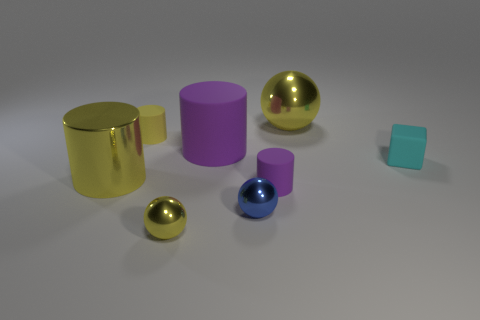Add 1 small blue spheres. How many objects exist? 9 Subtract all yellow matte cylinders. How many cylinders are left? 3 Subtract 2 cylinders. How many cylinders are left? 2 Subtract all green blocks. How many yellow spheres are left? 2 Subtract all small purple matte balls. Subtract all tiny metallic spheres. How many objects are left? 6 Add 1 matte things. How many matte things are left? 5 Add 7 large cylinders. How many large cylinders exist? 9 Subtract all blue spheres. How many spheres are left? 2 Subtract 1 blue balls. How many objects are left? 7 Subtract all spheres. How many objects are left? 5 